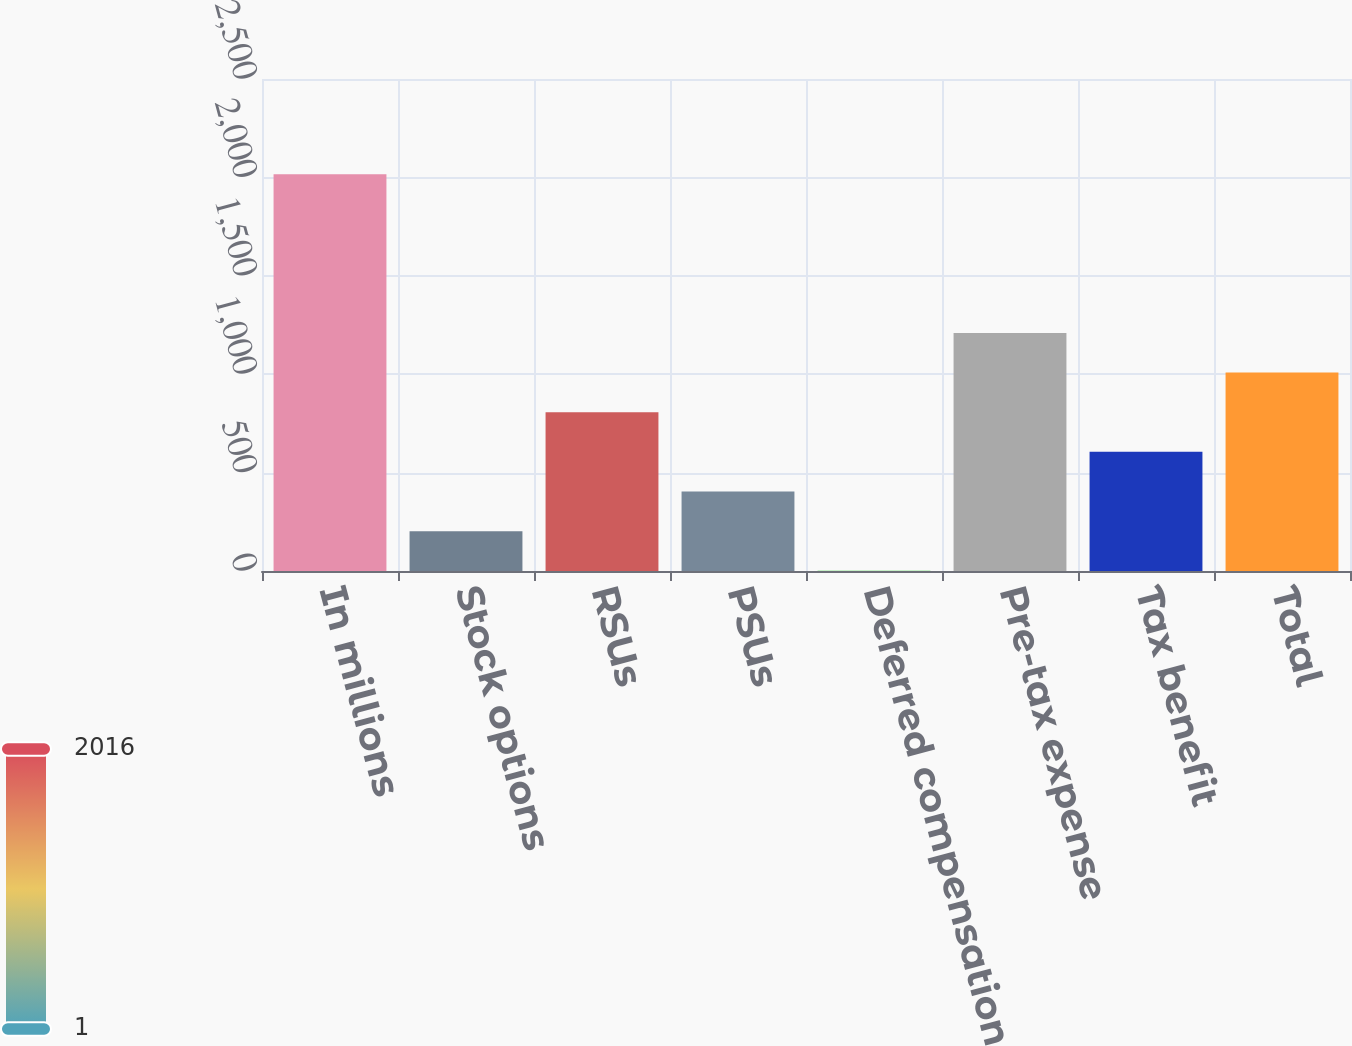<chart> <loc_0><loc_0><loc_500><loc_500><bar_chart><fcel>In millions<fcel>Stock options<fcel>RSUs<fcel>PSUs<fcel>Deferred compensation<fcel>Pre-tax expense<fcel>Tax benefit<fcel>Total<nl><fcel>2016<fcel>202.32<fcel>806.88<fcel>403.84<fcel>0.8<fcel>1209.92<fcel>605.36<fcel>1008.4<nl></chart> 